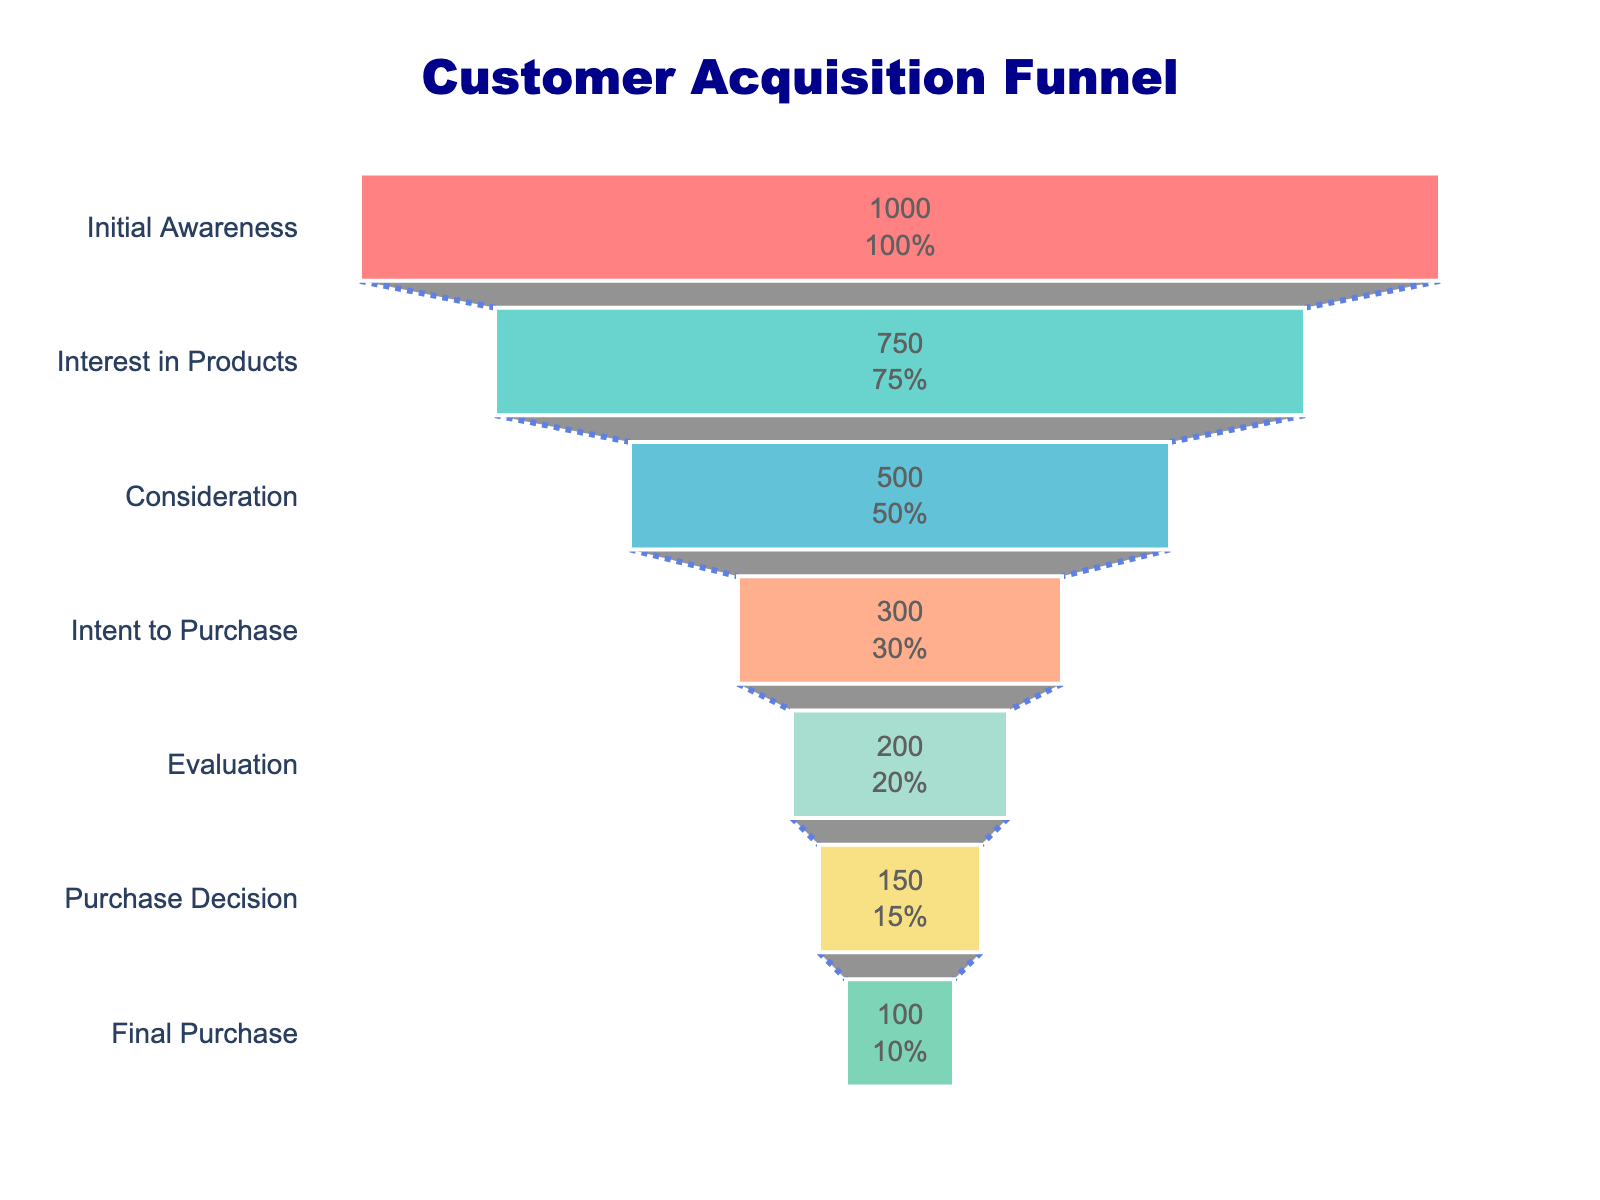What is the title of the funnel chart? The title is usually located at the top of the chart and is often used to explain the chart's content. In this case, there is a title at the top of the chart which reads "Customer Acquisition Funnel".
Answer: Customer Acquisition Funnel How many stages are there in the funnel? The chart lists each stage on the y-axis. By counting these stages, we see that there are seven stages listed from top to bottom.
Answer: 7 What percentage of customers reach the final purchase stage compared to the initial awareness stage? The final purchase stage shows the number of customers as 100, and the initial awareness stage shows 1000. The percentage can be calculated as (100 / 1000) * 100 = 10%.
Answer: 10% Which stage experiences the biggest drop in the number of customers? By comparing the number of customers between each successive stage: Initial Awareness to Interest in Products (1000 to 750), Interest in Products to Consideration (750 to 500), etc. The largest drop is from Consideration to Intent to Purchase, which is 500 to 300 (200 customers).
Answer: Consideration to Intent to Purchase What is the difference in customer number between the Evaluation and Purchase Decision stages? The number of customers in the Evaluation stage is 200 and in the Purchase Decision stage is 150. The difference can be calculated as 200 - 150 = 50 customers.
Answer: 50 How many customers are lost between the Initial Awareness stage and the Interest in Products stage? The number of customers at the Initial Awareness stage is 1000 and at the Interest in Products stage is 750. The number of lost customers can be found by 1000 - 750 = 250 customers.
Answer: 250 By what percentage do the customers decrease from the Interest in Products stage to the Consideration stage? The Interest in Products stage has 750 customers, and the Consideration stage has 500 customers. The percentage decrease is ((750 - 500) / 750) * 100 = 33.33%.
Answer: 33.33% Is the transition from Evaluation to Purchase Decision more or less significant than the transition from Intent to Purchase to Evaluation? From the chart, the number of customers goes from 200 to 150 between Evaluation and Purchase Decision, a drop of 50, and from Intent to Purchase to Evaluation, it goes from 300 to 200, a drop of 100. Therefore, the transition from Intent to Purchase to Evaluation is more significant.
Answer: Less significant Which color represents the Intent to Purchase stage in the funnel chart? Colors are assigned to each stage, and by observing the chart, the Intent to Purchase stage is represented by the orange color.
Answer: Orange What is the proportion of customers at the Purchase Decision stage as a percentage of those at the Consideration stage? Customers at the Purchase Decision stage are 150 and at the Consideration stage are 500. The proportion is (150 / 500) * 100 = 30%.
Answer: 30% 